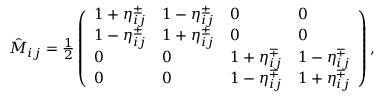Convert formula to latex. <formula><loc_0><loc_0><loc_500><loc_500>\begin{array} { r } { \hat { M } _ { i j } = \frac { 1 } { 2 } \left ( \begin{array} { l l l l } { 1 + \eta _ { i j } ^ { \pm } } & { 1 - \eta _ { i j } ^ { \pm } } & { 0 } & { 0 } \\ { 1 - \eta _ { i j } ^ { \pm } } & { 1 + \eta _ { i j } ^ { \pm } } & { 0 } & { 0 } \\ { 0 } & { 0 } & { 1 + \eta _ { i j } ^ { \mp } } & { 1 - \eta _ { i j } ^ { \mp } } \\ { 0 } & { 0 } & { 1 - \eta _ { i j } ^ { \mp } } & { 1 + \eta _ { i j } ^ { \mp } } \end{array} \right ) , } \end{array}</formula> 